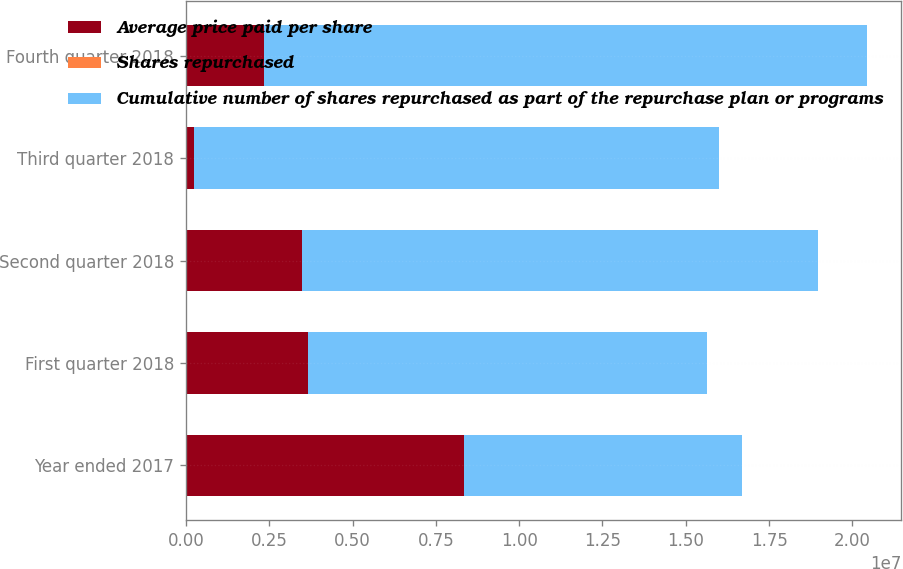Convert chart to OTSL. <chart><loc_0><loc_0><loc_500><loc_500><stacked_bar_chart><ecel><fcel>Year ended 2017<fcel>First quarter 2018<fcel>Second quarter 2018<fcel>Third quarter 2018<fcel>Fourth quarter 2018<nl><fcel>Average price paid per share<fcel>8.34241e+06<fcel>3.65393e+06<fcel>3.47955e+06<fcel>252947<fcel>2.35848e+06<nl><fcel>Shares repurchased<fcel>101.64<fcel>97.07<fcel>97.22<fcel>99.75<fcel>93.04<nl><fcel>Cumulative number of shares repurchased as part of the repurchase plan or programs<fcel>8.34241e+06<fcel>1.19963e+07<fcel>1.54759e+07<fcel>1.57288e+07<fcel>1.80873e+07<nl></chart> 